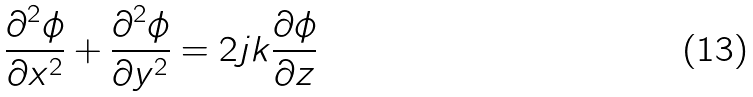<formula> <loc_0><loc_0><loc_500><loc_500>\frac { \partial ^ { 2 } \phi } { \partial x ^ { 2 } } + \frac { \partial ^ { 2 } \phi } { \partial y ^ { 2 } } = 2 j k \frac { \partial \phi } { \partial z }</formula> 